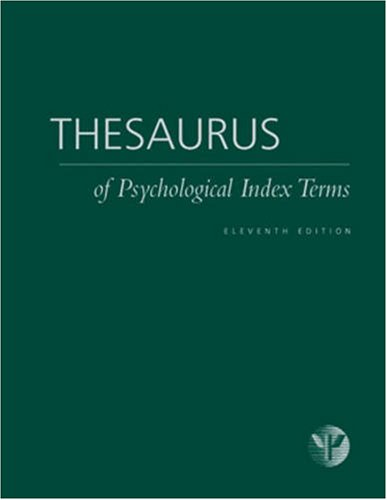What type of book is this? This is a reference book, specifically designed to provide a comprehensive list and explanation of terms used in the field of psychology, aiding academic and professional use. 